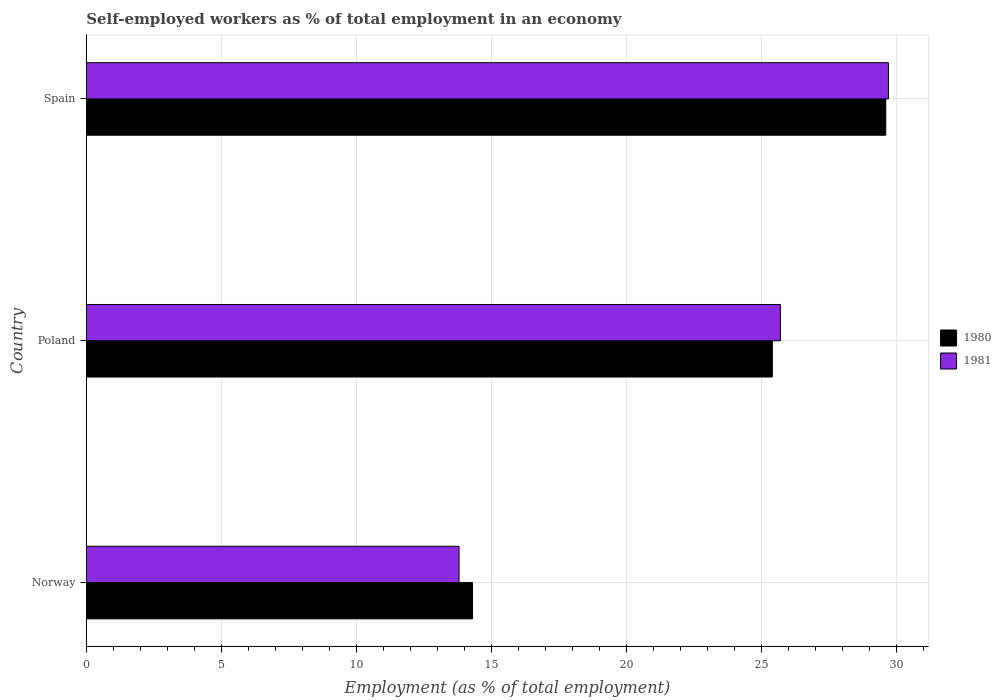How many groups of bars are there?
Give a very brief answer. 3. Are the number of bars per tick equal to the number of legend labels?
Provide a succinct answer. Yes. How many bars are there on the 1st tick from the bottom?
Provide a short and direct response. 2. What is the label of the 1st group of bars from the top?
Your response must be concise. Spain. In how many cases, is the number of bars for a given country not equal to the number of legend labels?
Give a very brief answer. 0. What is the percentage of self-employed workers in 1981 in Spain?
Keep it short and to the point. 29.7. Across all countries, what is the maximum percentage of self-employed workers in 1980?
Your answer should be compact. 29.6. Across all countries, what is the minimum percentage of self-employed workers in 1980?
Provide a short and direct response. 14.3. What is the total percentage of self-employed workers in 1980 in the graph?
Make the answer very short. 69.3. What is the difference between the percentage of self-employed workers in 1981 in Poland and that in Spain?
Make the answer very short. -4. What is the difference between the percentage of self-employed workers in 1980 in Poland and the percentage of self-employed workers in 1981 in Norway?
Your answer should be very brief. 11.6. What is the average percentage of self-employed workers in 1980 per country?
Your response must be concise. 23.1. What is the ratio of the percentage of self-employed workers in 1980 in Norway to that in Poland?
Offer a terse response. 0.56. Is the difference between the percentage of self-employed workers in 1981 in Poland and Spain greater than the difference between the percentage of self-employed workers in 1980 in Poland and Spain?
Provide a short and direct response. Yes. What is the difference between the highest and the second highest percentage of self-employed workers in 1980?
Offer a terse response. 4.2. What is the difference between the highest and the lowest percentage of self-employed workers in 1981?
Your answer should be very brief. 15.9. In how many countries, is the percentage of self-employed workers in 1981 greater than the average percentage of self-employed workers in 1981 taken over all countries?
Keep it short and to the point. 2. What does the 1st bar from the top in Poland represents?
Your answer should be very brief. 1981. How many bars are there?
Ensure brevity in your answer.  6. What is the difference between two consecutive major ticks on the X-axis?
Make the answer very short. 5. Does the graph contain any zero values?
Your answer should be very brief. No. Where does the legend appear in the graph?
Ensure brevity in your answer.  Center right. How many legend labels are there?
Offer a very short reply. 2. What is the title of the graph?
Keep it short and to the point. Self-employed workers as % of total employment in an economy. Does "1998" appear as one of the legend labels in the graph?
Make the answer very short. No. What is the label or title of the X-axis?
Offer a terse response. Employment (as % of total employment). What is the label or title of the Y-axis?
Your answer should be very brief. Country. What is the Employment (as % of total employment) of 1980 in Norway?
Your answer should be very brief. 14.3. What is the Employment (as % of total employment) in 1981 in Norway?
Keep it short and to the point. 13.8. What is the Employment (as % of total employment) of 1980 in Poland?
Your response must be concise. 25.4. What is the Employment (as % of total employment) of 1981 in Poland?
Offer a very short reply. 25.7. What is the Employment (as % of total employment) of 1980 in Spain?
Ensure brevity in your answer.  29.6. What is the Employment (as % of total employment) of 1981 in Spain?
Provide a short and direct response. 29.7. Across all countries, what is the maximum Employment (as % of total employment) of 1980?
Make the answer very short. 29.6. Across all countries, what is the maximum Employment (as % of total employment) of 1981?
Ensure brevity in your answer.  29.7. Across all countries, what is the minimum Employment (as % of total employment) in 1980?
Give a very brief answer. 14.3. Across all countries, what is the minimum Employment (as % of total employment) of 1981?
Your answer should be compact. 13.8. What is the total Employment (as % of total employment) in 1980 in the graph?
Offer a very short reply. 69.3. What is the total Employment (as % of total employment) in 1981 in the graph?
Your answer should be compact. 69.2. What is the difference between the Employment (as % of total employment) of 1980 in Norway and that in Poland?
Make the answer very short. -11.1. What is the difference between the Employment (as % of total employment) of 1980 in Norway and that in Spain?
Ensure brevity in your answer.  -15.3. What is the difference between the Employment (as % of total employment) in 1981 in Norway and that in Spain?
Offer a very short reply. -15.9. What is the difference between the Employment (as % of total employment) of 1981 in Poland and that in Spain?
Make the answer very short. -4. What is the difference between the Employment (as % of total employment) of 1980 in Norway and the Employment (as % of total employment) of 1981 in Poland?
Make the answer very short. -11.4. What is the difference between the Employment (as % of total employment) of 1980 in Norway and the Employment (as % of total employment) of 1981 in Spain?
Your answer should be very brief. -15.4. What is the difference between the Employment (as % of total employment) in 1980 in Poland and the Employment (as % of total employment) in 1981 in Spain?
Provide a succinct answer. -4.3. What is the average Employment (as % of total employment) in 1980 per country?
Your answer should be very brief. 23.1. What is the average Employment (as % of total employment) in 1981 per country?
Give a very brief answer. 23.07. What is the ratio of the Employment (as % of total employment) of 1980 in Norway to that in Poland?
Your response must be concise. 0.56. What is the ratio of the Employment (as % of total employment) of 1981 in Norway to that in Poland?
Offer a very short reply. 0.54. What is the ratio of the Employment (as % of total employment) of 1980 in Norway to that in Spain?
Provide a short and direct response. 0.48. What is the ratio of the Employment (as % of total employment) of 1981 in Norway to that in Spain?
Keep it short and to the point. 0.46. What is the ratio of the Employment (as % of total employment) of 1980 in Poland to that in Spain?
Your answer should be compact. 0.86. What is the ratio of the Employment (as % of total employment) in 1981 in Poland to that in Spain?
Your answer should be compact. 0.87. What is the difference between the highest and the second highest Employment (as % of total employment) in 1980?
Your answer should be compact. 4.2. What is the difference between the highest and the second highest Employment (as % of total employment) in 1981?
Offer a very short reply. 4. What is the difference between the highest and the lowest Employment (as % of total employment) of 1980?
Your response must be concise. 15.3. 